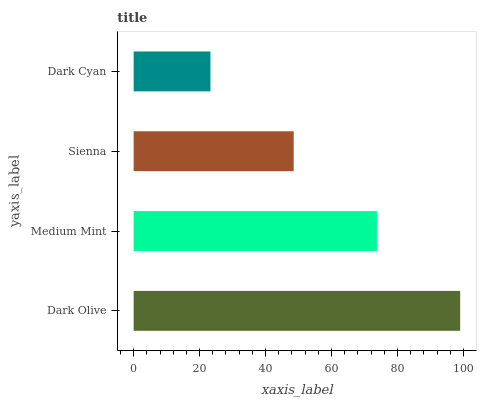Is Dark Cyan the minimum?
Answer yes or no. Yes. Is Dark Olive the maximum?
Answer yes or no. Yes. Is Medium Mint the minimum?
Answer yes or no. No. Is Medium Mint the maximum?
Answer yes or no. No. Is Dark Olive greater than Medium Mint?
Answer yes or no. Yes. Is Medium Mint less than Dark Olive?
Answer yes or no. Yes. Is Medium Mint greater than Dark Olive?
Answer yes or no. No. Is Dark Olive less than Medium Mint?
Answer yes or no. No. Is Medium Mint the high median?
Answer yes or no. Yes. Is Sienna the low median?
Answer yes or no. Yes. Is Dark Cyan the high median?
Answer yes or no. No. Is Medium Mint the low median?
Answer yes or no. No. 